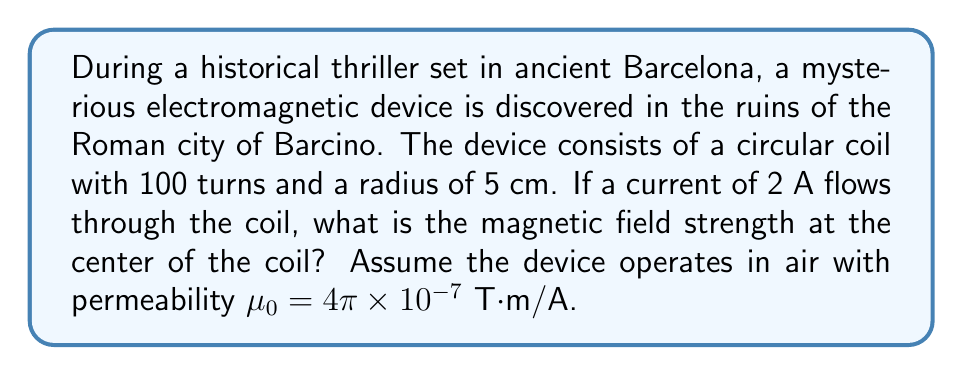Provide a solution to this math problem. To solve this problem, we'll use the formula for the magnetic field strength at the center of a circular coil:

$$B = \frac{\mu_0 N I}{2R}$$

Where:
$B$ = magnetic field strength (T)
$\mu_0$ = permeability of free space (T⋅m/A)
$N$ = number of turns in the coil
$I$ = current flowing through the coil (A)
$R$ = radius of the coil (m)

Given:
$\mu_0 = 4\pi \times 10^{-7}$ T⋅m/A
$N = 100$ turns
$I = 2$ A
$R = 5$ cm $= 0.05$ m

Let's substitute these values into the equation:

$$B = \frac{(4\pi \times 10^{-7})(100)(2)}{2(0.05)}$$

Simplifying:

$$B = \frac{8\pi \times 10^{-5}}{0.1}$$

$$B = 8\pi \times 10^{-4}$$

$$B \approx 2.51 \times 10^{-3}$$ T
Answer: $2.51 \times 10^{-3}$ T 